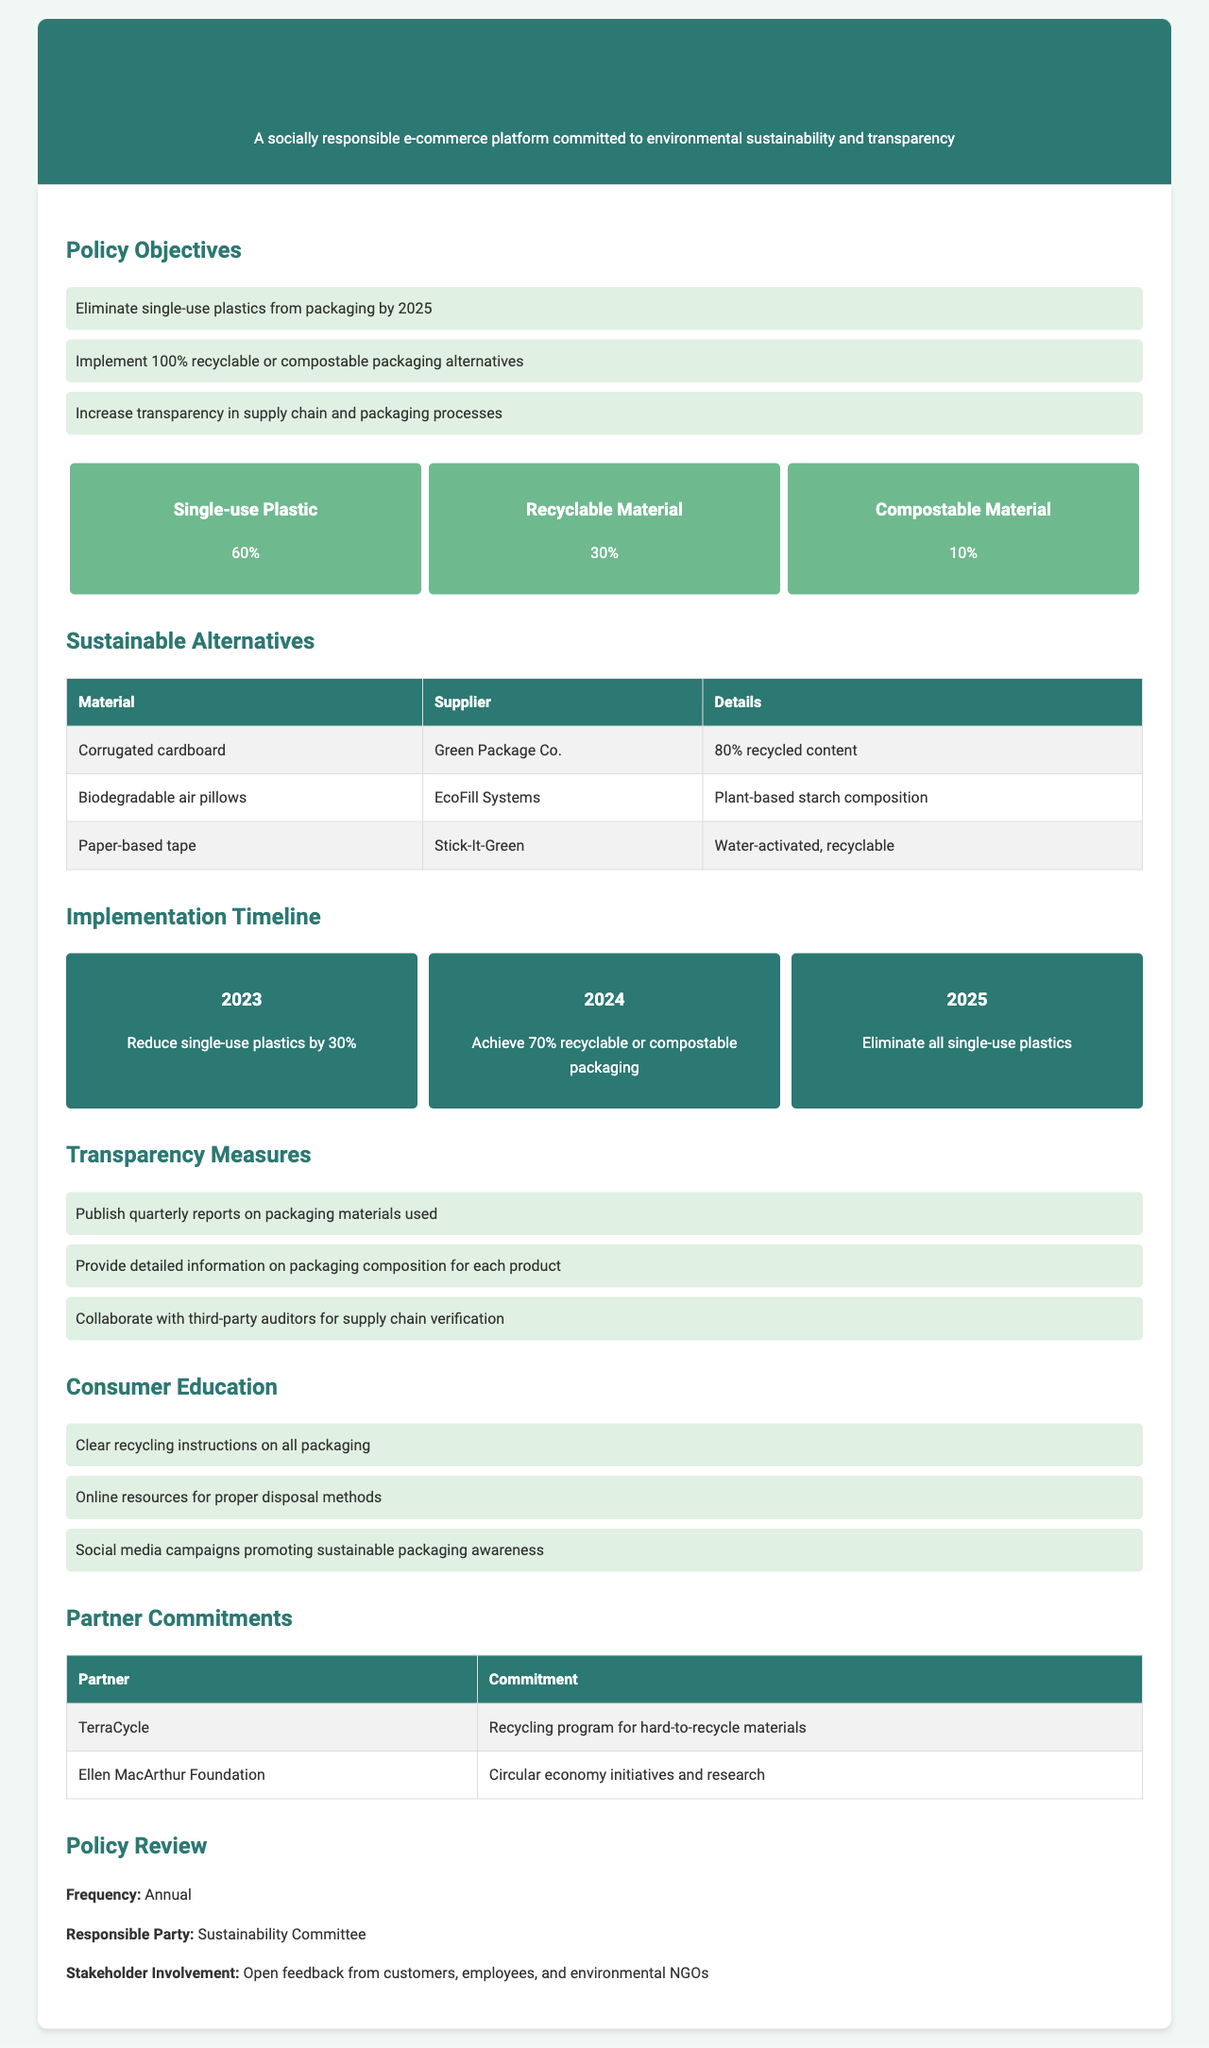What is the target year to eliminate single-use plastics? The policy states that the goal is to eliminate single-use plastics from packaging by the year 2025.
Answer: 2025 What percentage of recyclable materials is currently used? The document indicates that currently, 30% of the materials used are recyclable.
Answer: 30% Who supplies the biodegradable air pillows? The supply for biodegradable air pillows is provided by EcoFill Systems.
Answer: EcoFill Systems What is the commitment of the partner TerraCycle? The document mentions that TerraCycle is committed to a recycling program for hard-to-recycle materials.
Answer: Recycling program for hard-to-recycle materials What year aims to achieve 70% recyclable or compostable packaging? According to the timeline, the year 2024 aims to achieve 70% recyclable or compostable packaging.
Answer: 2024 How often will the policy be reviewed? The policy review frequency is specified as annual in the document.
Answer: Annual What are the three main components of the policy objectives? The three main components are eliminating single-use plastics, implementing 100% recyclable alternatives, and increasing supply chain transparency.
Answer: Eliminate single-use plastics, 100% recyclable alternatives, increase transparency Who is responsible for the annual policy review? The document states that the responsible party for the policy review is the Sustainability Committee.
Answer: Sustainability Committee Which organization is engaged in circular economy initiatives? The Ellen MacArthur Foundation is mentioned in the document as engaging in circular economy initiatives.
Answer: Ellen MacArthur Foundation 